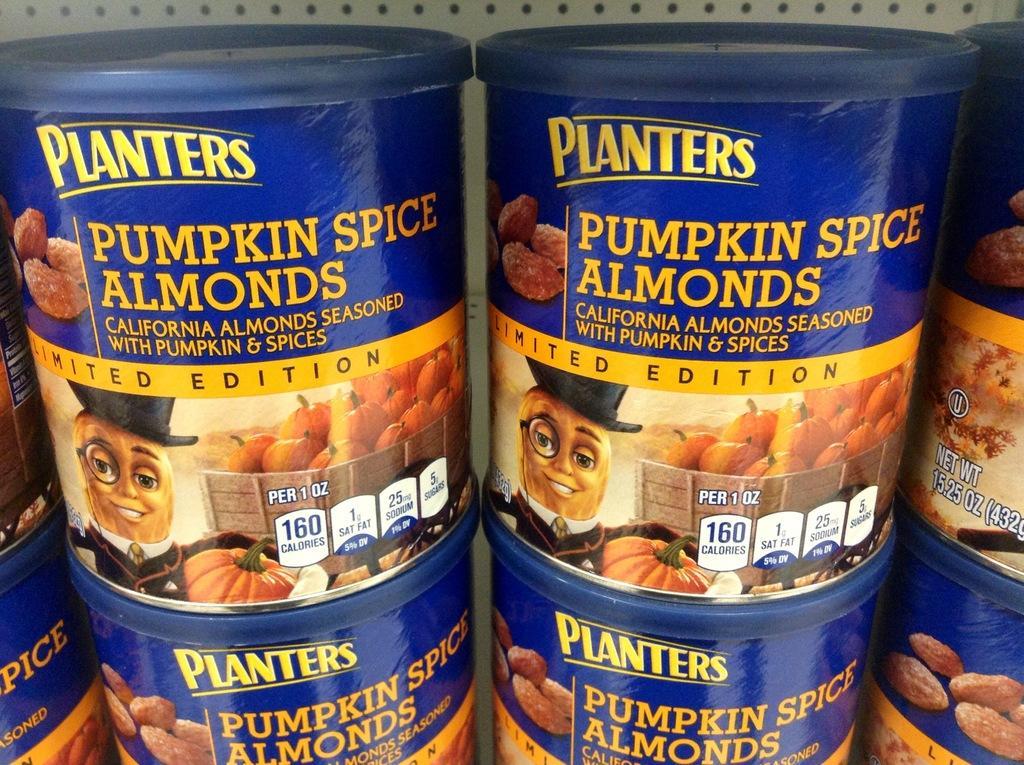How would you summarize this image in a sentence or two? In this image I can see few boxes which are blue in color in the rocks which are white in color. On the boxes I can see pictures of few fruits and few words printed. 